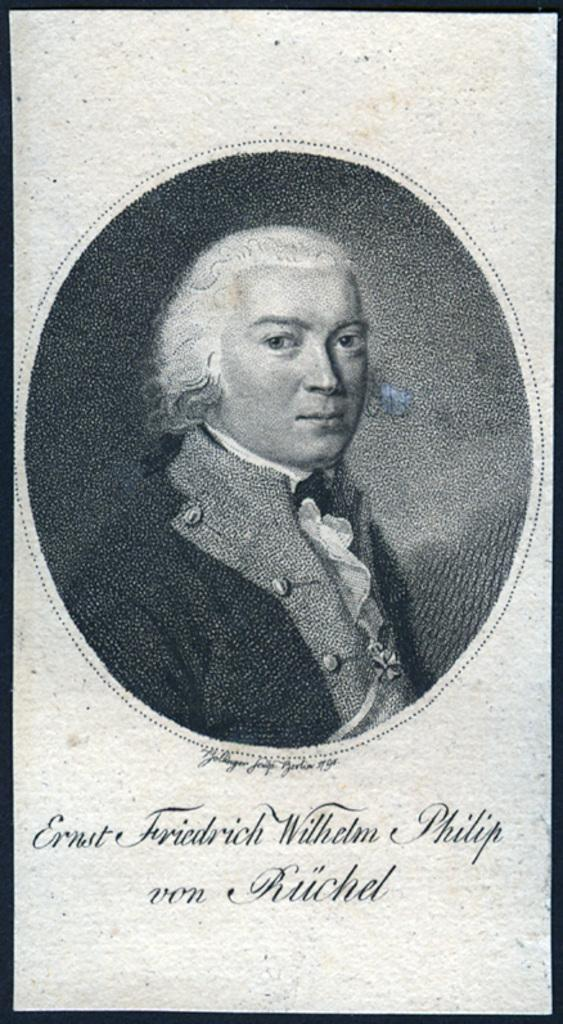What is present in the image that features a person? There is a poster in the image that features a person. What else can be seen on the poster besides the person? There is writing on the poster. What type of throne is the person sitting on in the image? There is no throne present in the image; it features a poster with a person and writing. What shape is the pig in the image? There is no pig present in the image. 